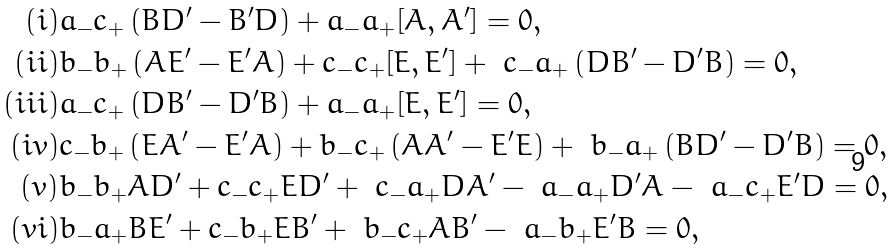Convert formula to latex. <formula><loc_0><loc_0><loc_500><loc_500>( i ) & a _ { - } c _ { + } \left ( B D ^ { \prime } - B ^ { \prime } D \right ) + a _ { - } a _ { + } [ A , A ^ { \prime } ] = 0 , \\ ( i i ) & b _ { - } b _ { + } \left ( A E ^ { \prime } - E ^ { \prime } A \right ) + c _ { - } c _ { + } [ E , E ^ { \prime } ] + \ c _ { - } a _ { + } \left ( D B ^ { \prime } - D ^ { \prime } B \right ) = 0 , \\ ( i i i ) & a _ { - } c _ { + } \left ( D B ^ { \prime } - D ^ { \prime } B \right ) + a _ { - } a _ { + } [ E , E ^ { \prime } ] = 0 , \\ ( i v ) & c _ { - } b _ { + } \left ( E A ^ { \prime } - E ^ { \prime } A \right ) + b _ { - } c _ { + } \left ( A A ^ { \prime } - E ^ { \prime } E \right ) + \ b _ { - } a _ { + } \left ( B D ^ { \prime } - D ^ { \prime } B \right ) = 0 , \\ ( v ) & b _ { - } b _ { + } A D ^ { \prime } + c _ { - } c _ { + } E D ^ { \prime } + \ c _ { - } a _ { + } D A ^ { \prime } - \ a _ { - } a _ { + } D ^ { \prime } A - \ a _ { - } c _ { + } E ^ { \prime } D = 0 , \\ ( v i ) & b _ { - } a _ { + } B E ^ { \prime } + c _ { - } b _ { + } E B ^ { \prime } + \ b _ { - } c _ { + } A B ^ { \prime } - \ a _ { - } b _ { + } E ^ { \prime } B = 0 ,</formula> 